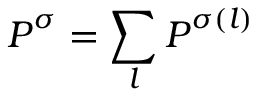Convert formula to latex. <formula><loc_0><loc_0><loc_500><loc_500>P ^ { \sigma } = \sum _ { l } P ^ { \sigma ( l ) }</formula> 